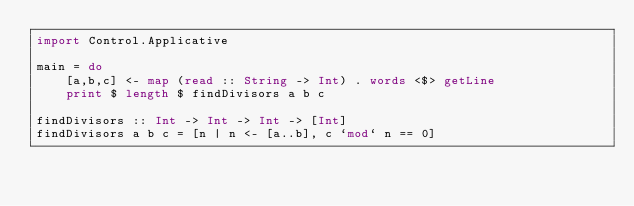<code> <loc_0><loc_0><loc_500><loc_500><_Haskell_>import Control.Applicative

main = do
    [a,b,c] <- map (read :: String -> Int) . words <$> getLine
    print $ length $ findDivisors a b c

findDivisors :: Int -> Int -> Int -> [Int]
findDivisors a b c = [n | n <- [a..b], c `mod` n == 0]
</code> 